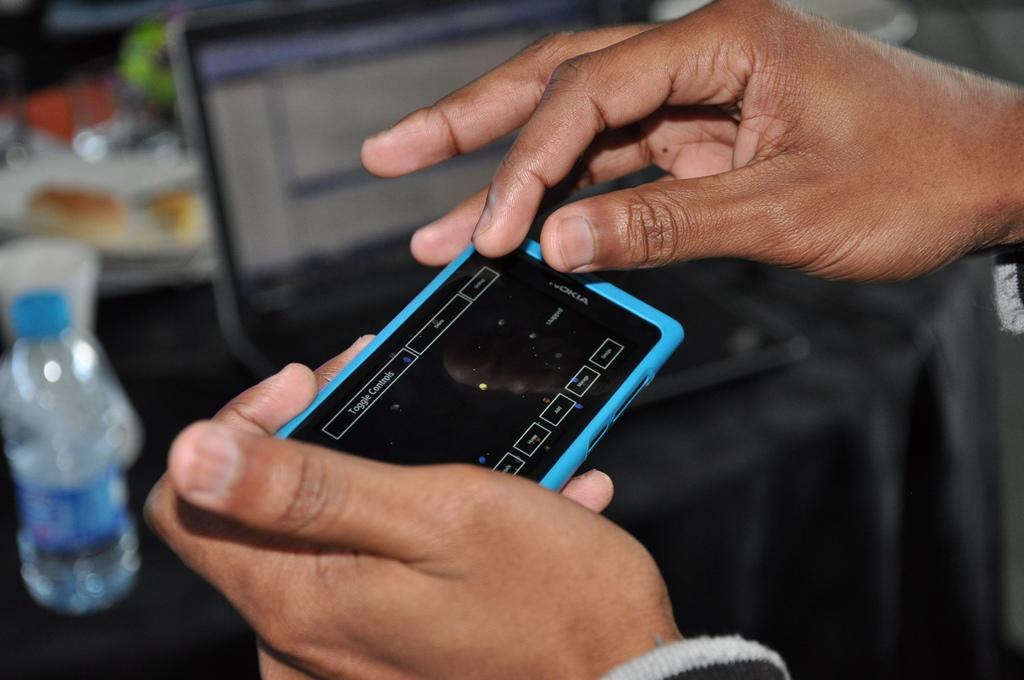<image>
Create a compact narrative representing the image presented. A person holds a phone on which the words toggle controls are visible. 